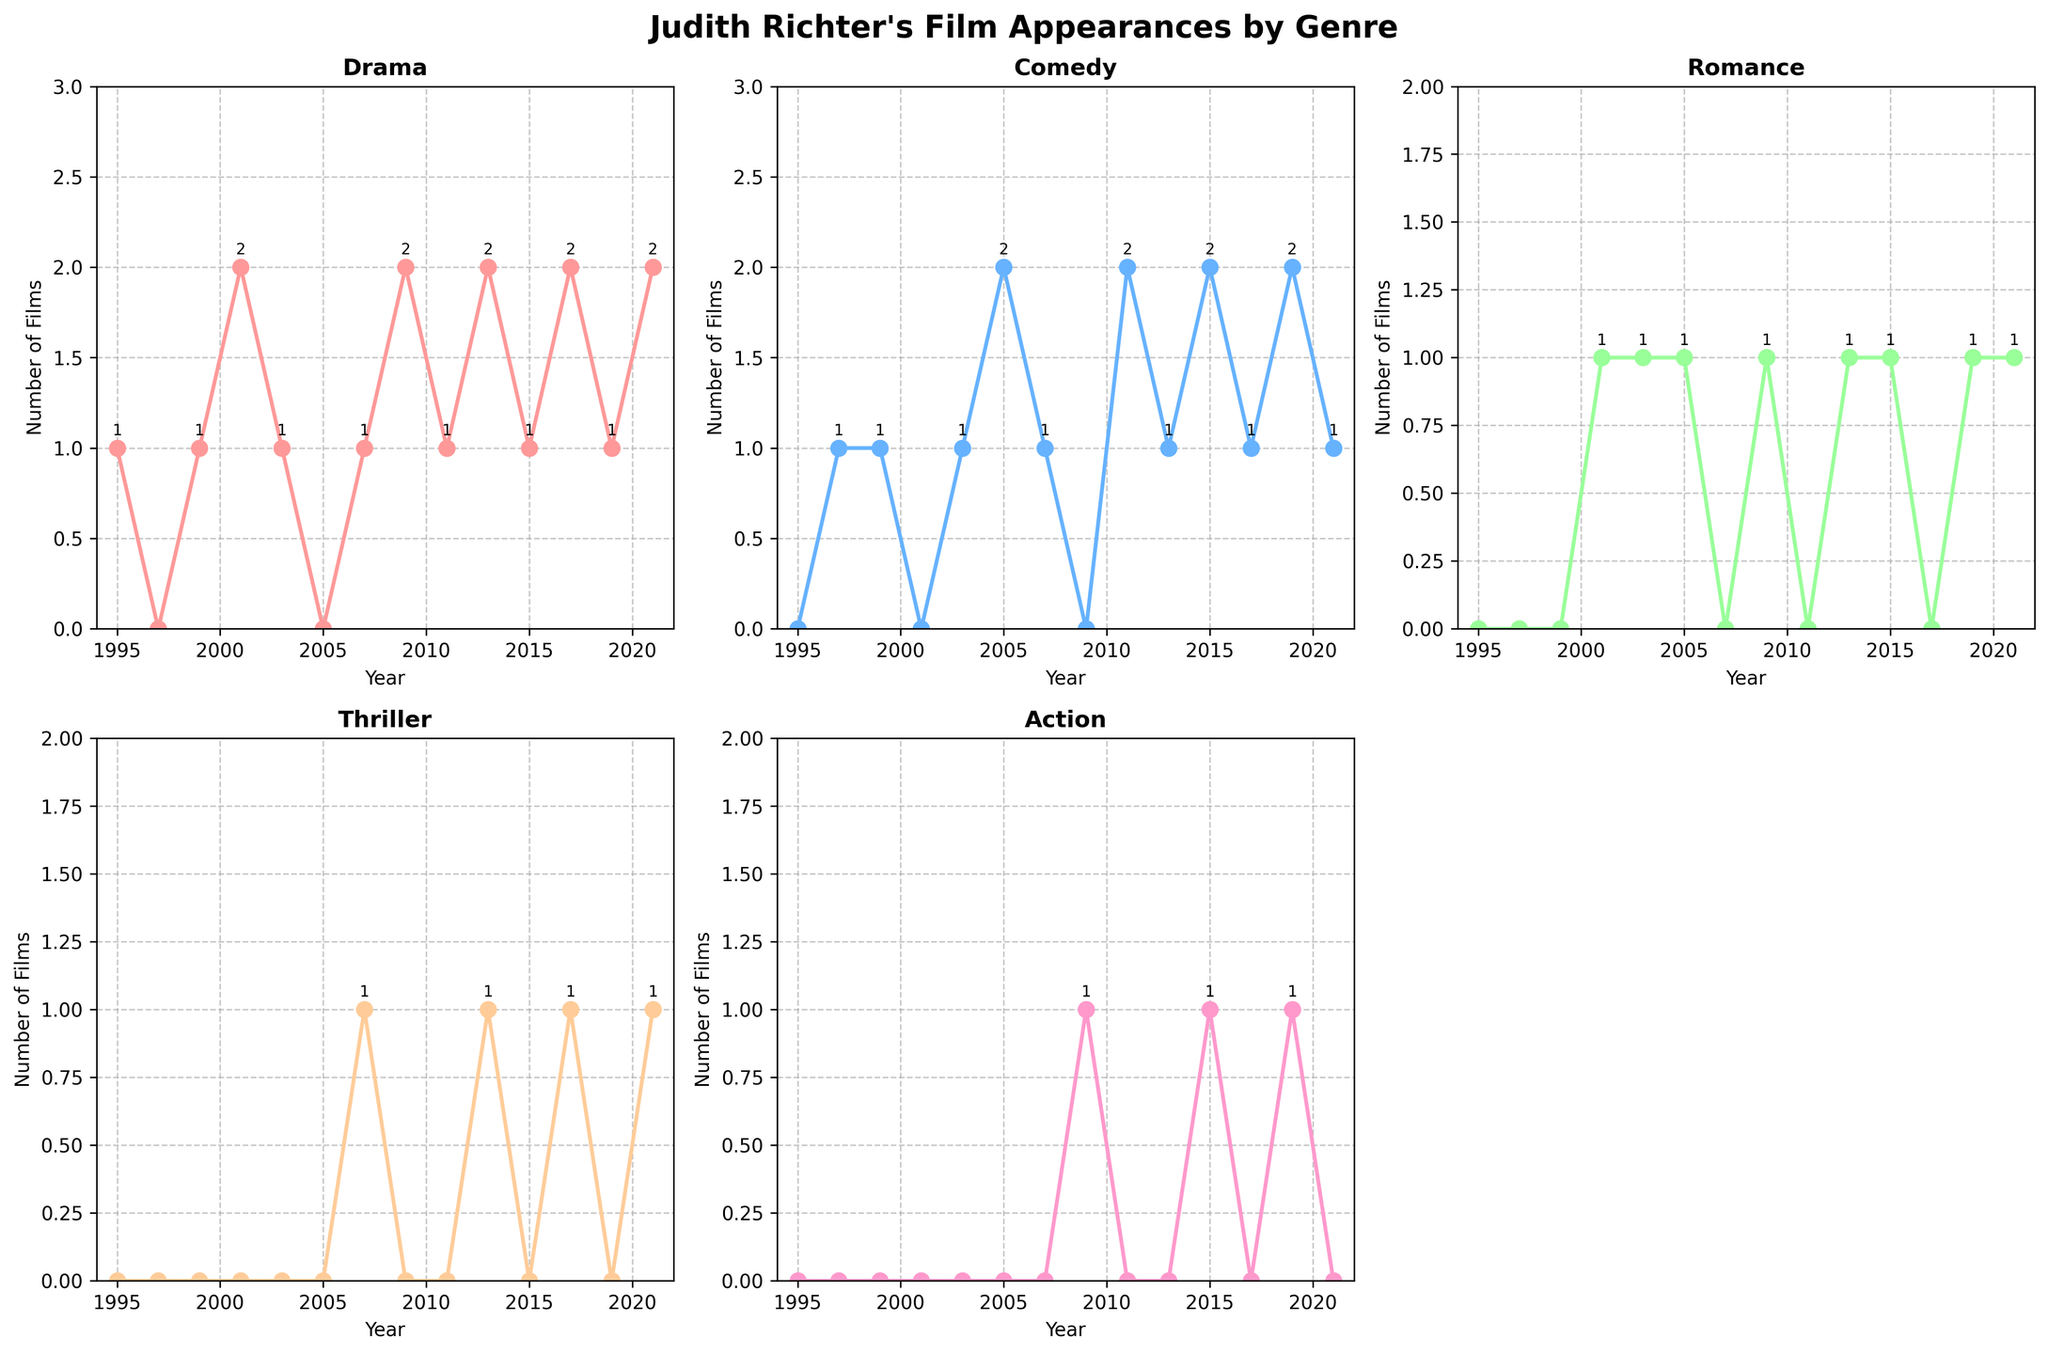what is the total number of Drama films Judith Richter appeared in from 1995 to 2021? To determine the total number of Drama films, we sum the number of Drama films per year from 1995 to 2021: 1+1+2+1+2+1+2+1+2 = 15.
Answer: 15 In which year did Judith Richter appear in the most Comedy films? We compare the number of Comedy films in each year. The years with the highest value are 2005, 2011, 2015, and 2019, each with 2 Comedy films.
Answer: 2005, 2011, 2015, 2019 How many Romance films did Judith appear in for the years where she also appeared in at least one Action film? We identify the years in which there is at least one Action film (2009, 2015, 2019) and sum the number of Romance films for those years: 1+1+1=3.
Answer: 3 What is the average number of Thriller films she appeared in every two years? The number of Thriller films in each year is: 0+0+0+1+1+1=3. There are 7 data points for Thriller films. Average per two years = (2*3)/(7/2)= 6/3.5=1.7142.
Answer: 1.7142 Which genre shows the most consistent number of films over the years? By visually observing the line plots for each genre, we notice that the line for Romance films is relatively consistent - often appearing in only one film per year.
Answer: Romance In which year did Judith Richter appear in more genres simultaneously? We look for the year with the highest count of appearances in multiple genres. In 2013 and 2021, she appeared in 4 different genres.
Answer: 2013, 2021 What is the total number of films Judith Richter appeared in during odd-numbered years? Adding the number of films in odd-numbered years: (1995: 1), (1997: 1), (1999: 1+1), (2001: 2+1), (2003: 1+1+1), (2005: 2+1), (2007: 1+1+1), (2009: 2+1+1), (2011: 1+2), (2013: 2+1+1+1), (2015: 1+2+1+1), (2017: 2+1+1), (2019: 1+2+1+1), (2021: 2+1+1+1) results in a total of 48 films.
Answer: 48 Which year had an equal number of Action and Thriller appearances? The years with appearances in both genres are 2007, 2013, and 2021. Comparing specific numbers of Thriller and Action for these years, in 2021, she has 1 Thriller and 1 Action film each.
Answer: 2021 What was the overall trend for Judith Richter's Comedy appearances from 1995 to 2021? Observing the line plot for Comedy films, we see relatively stable appearances with peaks at 2005, 2011, 2015, and 2019 each with 2 films. This indicates sporadic increases followed by periods of moderate appearances.
Answer: Sporadic increases with periods of moderate appearances How many more Drama films did she appear in 2001 compared to 2005? In 2001, she appeared in 2 Drama films, and in 2005, she appeared in 0 Drama films. The difference is 2 - 0 = 2.
Answer: 2 